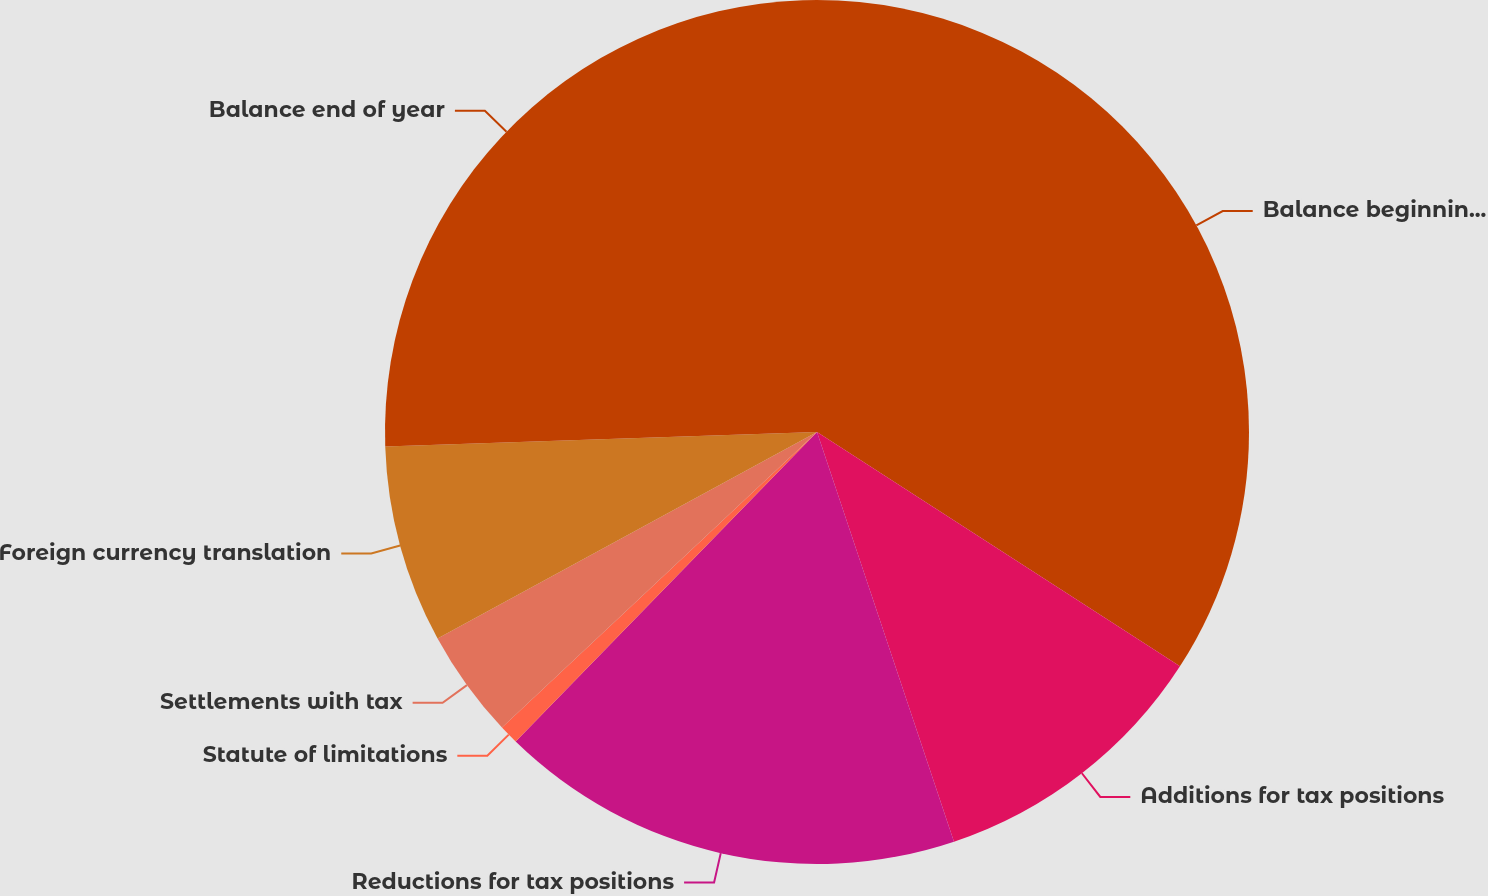<chart> <loc_0><loc_0><loc_500><loc_500><pie_chart><fcel>Balance beginning of year<fcel>Additions for tax positions<fcel>Reductions for tax positions<fcel>Statute of limitations<fcel>Settlements with tax<fcel>Foreign currency translation<fcel>Balance end of year<nl><fcel>34.12%<fcel>10.74%<fcel>17.42%<fcel>0.72%<fcel>4.06%<fcel>7.4%<fcel>25.53%<nl></chart> 